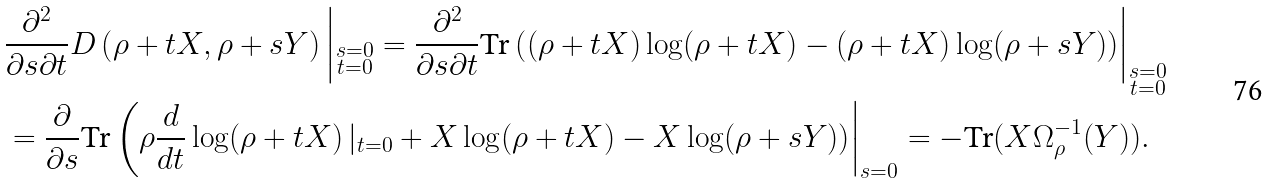<formula> <loc_0><loc_0><loc_500><loc_500>& \frac { \partial ^ { 2 } } { \partial s \partial t } D \left ( \rho + t X , \rho + s Y \right ) \left | _ { \substack { s = 0 \\ t = 0 } } = \frac { \partial ^ { 2 } } { \partial s \partial t } \text {Tr} \left ( ( \rho + t X ) \log ( \rho + t X ) - ( \rho + t X ) \log ( \rho + s Y ) \right ) \right | _ { \substack { s = 0 \\ t = 0 } } \\ & = \frac { \partial } { \partial s } \text {Tr} \left ( \rho \frac { d } { d t } \log ( \rho + t X ) \left | _ { t = 0 } + X \log ( \rho + t X ) - X \log ( \rho + s Y ) \right ) \right | _ { s = 0 } = - \text {Tr} ( X \Omega _ { \rho } ^ { - 1 } ( Y ) ) .</formula> 